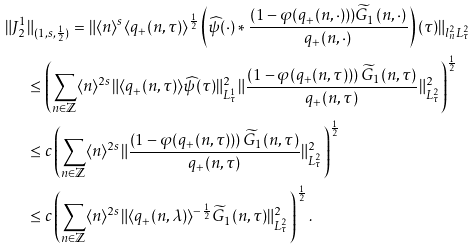Convert formula to latex. <formula><loc_0><loc_0><loc_500><loc_500>\| J _ { 2 } ^ { 1 } & \| _ { ( 1 , s , \frac { 1 } { 2 } ) } = \| \langle n \rangle ^ { s } \langle q _ { + } ( n , \tau ) \rangle ^ { \frac { 1 } { 2 } } \left ( \widehat { \psi } ( \cdot ) \ast \frac { ( 1 - \varphi ( q _ { + } ( n , \cdot ) ) ) \widetilde { G } _ { 1 } ( n , \cdot ) } { q _ { + } ( n , \cdot ) } \right ) ( \tau ) \| _ { l _ { n } ^ { 2 } L _ { \tau } ^ { 2 } } \\ & \leq \left ( \sum _ { n \in \mathbb { Z } } \langle n \rangle ^ { 2 s } \| \langle q _ { + } ( n , \tau ) \rangle \widehat { \psi } ( \tau ) \| _ { L _ { \tau } ^ { 1 } } ^ { 2 } \| \frac { \left ( 1 - \varphi ( q _ { + } ( n , \tau ) ) \right ) \widetilde { G } _ { 1 } ( n , \tau ) } { q _ { + } ( n , \tau ) } \| _ { L _ { \tau } ^ { 2 } } ^ { 2 } \right ) ^ { \frac { 1 } { 2 } } \\ & \leq c \left ( \sum _ { n \in \mathbb { Z } } \langle n \rangle ^ { 2 s } \| \frac { \left ( 1 - \varphi ( q _ { + } ( n , \tau ) ) \right ) \widetilde { G } _ { 1 } ( n , \tau ) } { q _ { + } ( n , \tau ) } \| _ { L _ { \tau } ^ { 2 } } ^ { 2 } \right ) ^ { \frac { 1 } { 2 } } \\ & \leq c \left ( \sum _ { n \in \mathbb { Z } } \langle n \rangle ^ { 2 s } \| \langle q _ { + } ( n , \lambda ) \rangle ^ { - \frac { 1 } { 2 } } \widetilde { G } _ { 1 } ( n , \tau ) \| _ { L _ { \tau } ^ { 2 } } ^ { 2 } \right ) ^ { \frac { 1 } { 2 } } .</formula> 